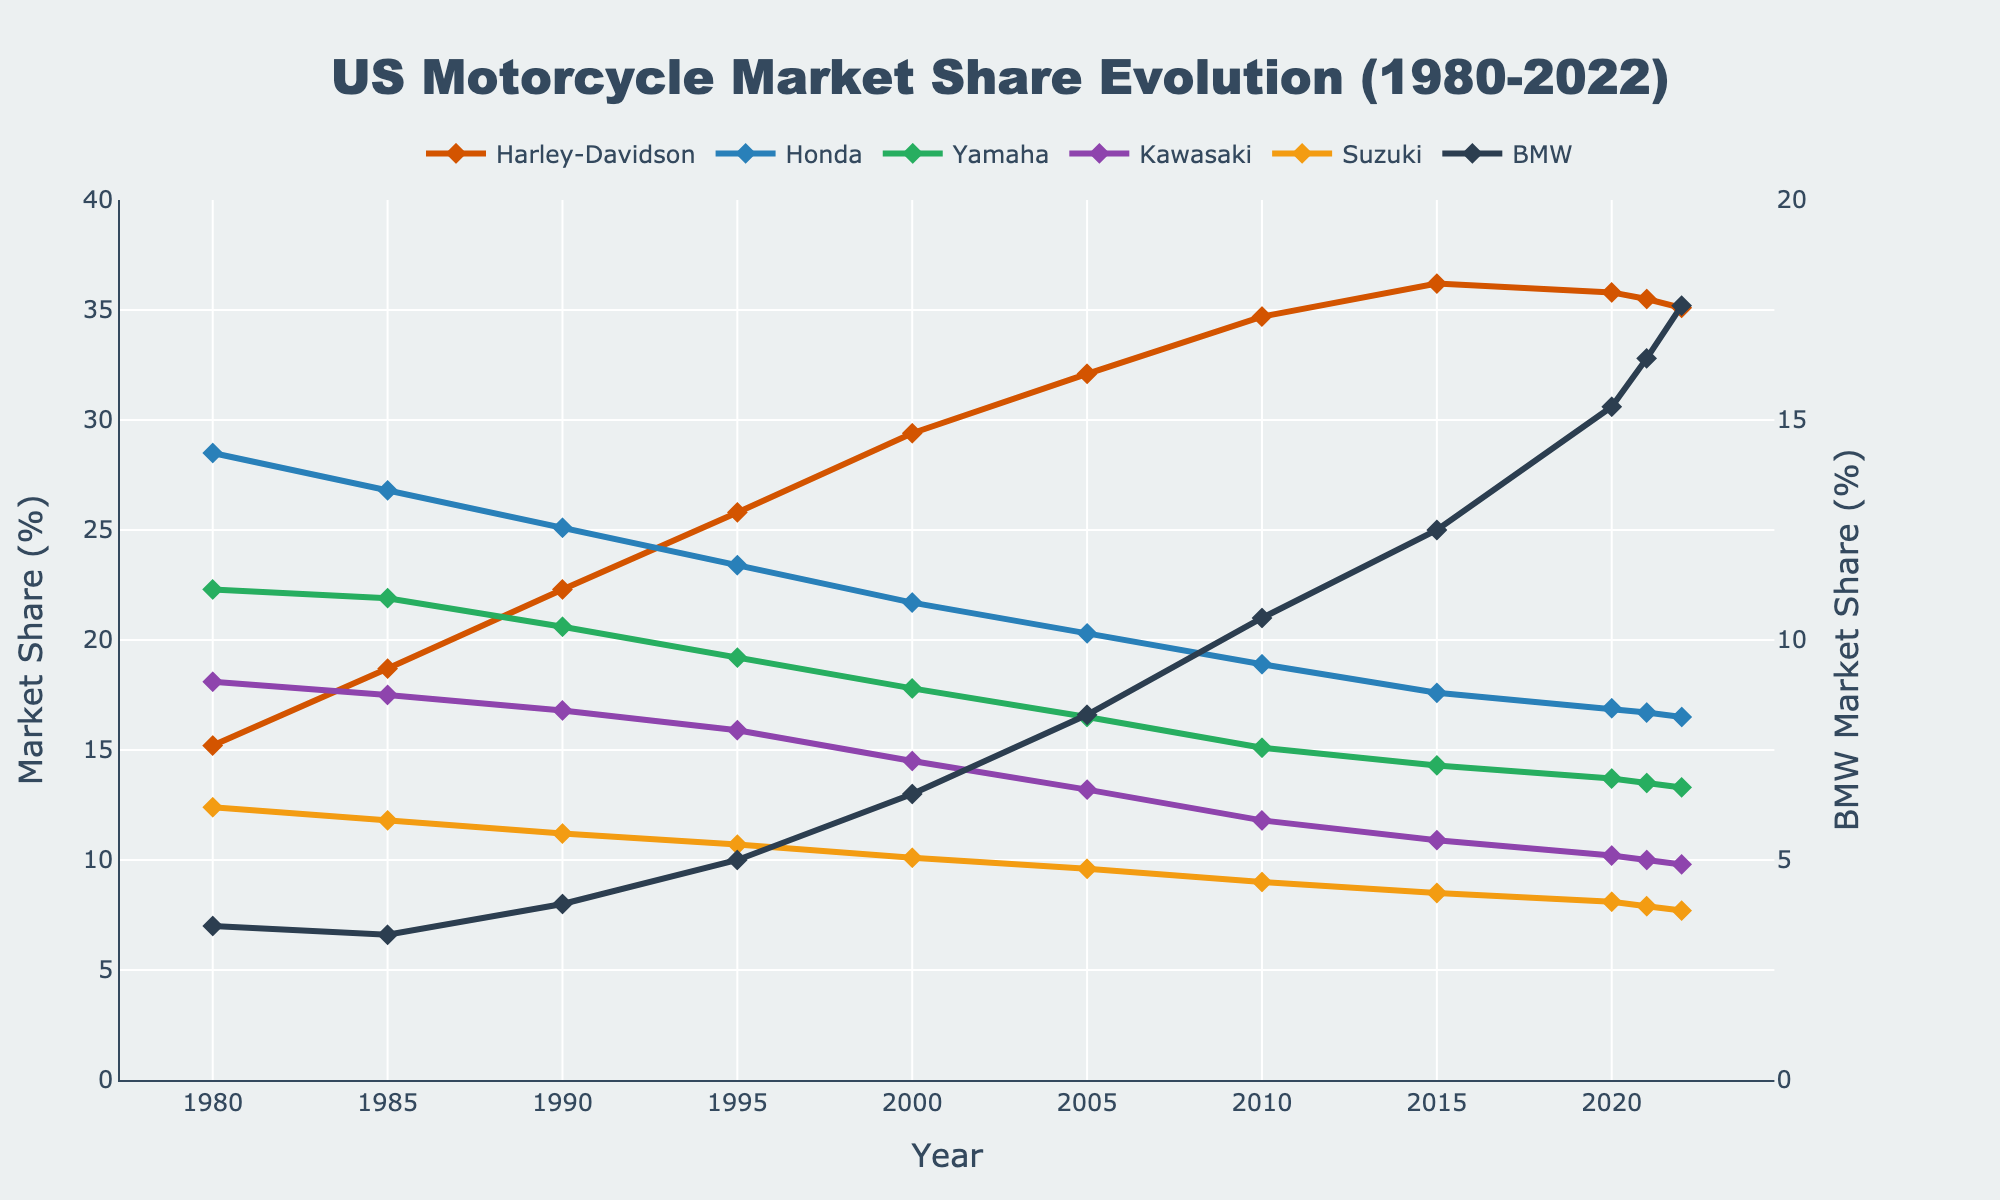Which manufacturer had the highest market share in 2022? By looking at the endpoints of each line at the year 2022, identify which manufacturer had the highest percentage. Harley-Davidson has the highest endpoint.
Answer: Harley-Davidson How did the market share of BMW change from 1980 to 2022? Track the trend of the BMW line from 1980 to 2022; it starts at a low point and rises gradually. It increased its market share.
Answer: Increased What was the combined market share of Harley-Davidson and Honda in 1990? Add the market shares of Harley-Davidson and Honda in 1990: 22.3% + 25.1% = 47.4%
Answer: 47.4% Which year did Yamaha's market share drop below 15%? Find the year where the Yamaha line first drops below the 15% mark. In 2010, it was 15.1%, and in 2015 it was 14.3%.
Answer: 2015 What is the difference in market share between Kawasaki and Suzuki in 2020? Subtract Suzuki's market share from Kawasaki's in 2020: 10.2% - 8.1% = 2.1%
Answer: 2.1% Which manufacturer showed the most consistent decline in market share over the years? Find the manufacturer with a consistently downward-sloping line trend throughout the chart. Honda's line consistently declines.
Answer: Honda When did Harley-Davidson's market share surpass 30%? Look for the first year Harley-Davidson's line crosses above the 30% mark, which happens after 2000 and by 2005.
Answer: 2005 Which manufacturer saw the most significant increase in market share from 1980 to 2022? Compare the increase in market share from 1980 to 2022 for each manufacturer. BMW increased from 3.5% to 17.6%.
Answer: BMW What was the average market share of Yamaha from 1980 to 2022? Sum all the market share values of Yamaha from 1980 to 2022 and divide by the number of data points: (22.3 + 21.9 + 20.6 + 19.2 + 17.8 + 16.5 + 15.1 + 14.3 + 13.7 + 13.5 + 13.3) / 11 = 17.3%
Answer: 17.3% How does the visual color of the trace representing Kawasaki differ from that of BMW? Identify the color used in the plot for Kawasaki and BMW. Kawasaki is represented by green, and BMW is represented by blue.
Answer: Kawasaki is green, BMW is blue 